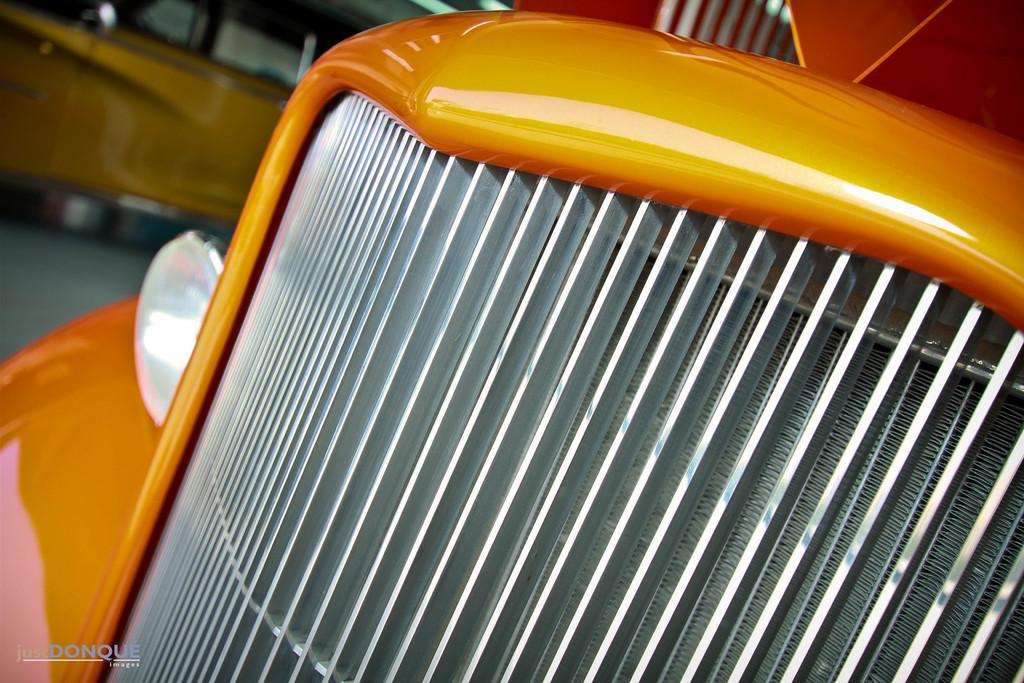What is the main subject of the image? The main subject of the image is a car. Can you describe the position of the car in the image? The car is located in the left top area of the image. How many chickens can be seen in the image? There are no chickens present in the image; it features a car. What type of pies is your aunt holding in the image? There is no aunt or pies present in the image. 